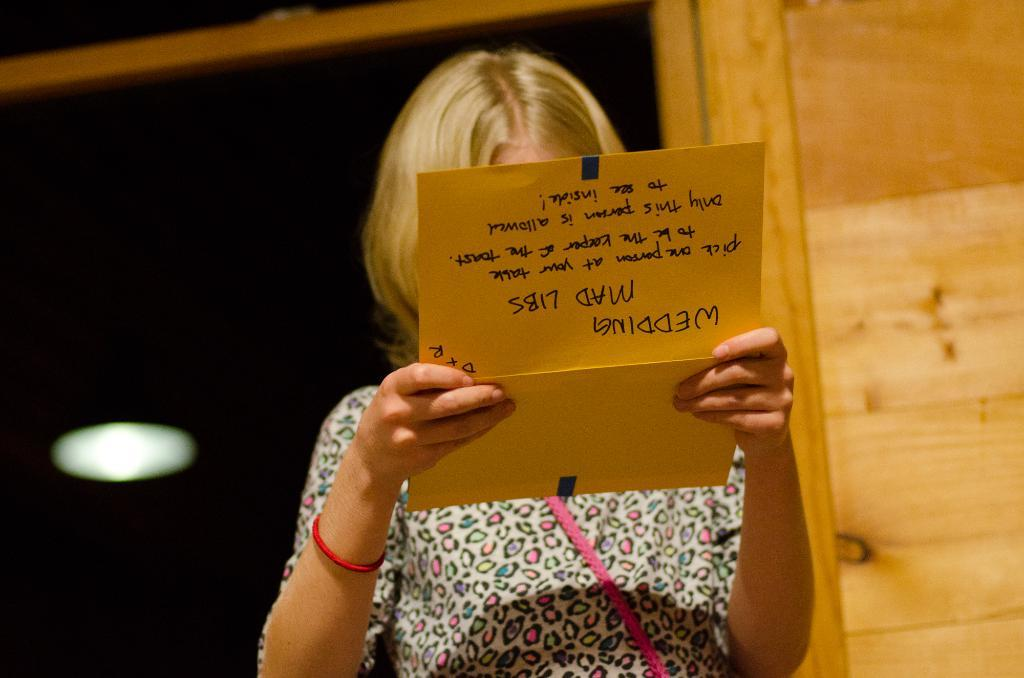Who is the main subject in the image? There is a woman in the image. What is the woman holding in the image? The woman is holding a card with text. Can you describe the lighting in the image? There is light on the ceiling in the image. How many eggs does the farmer need in the image? There is no farmer or eggs present in the image. 